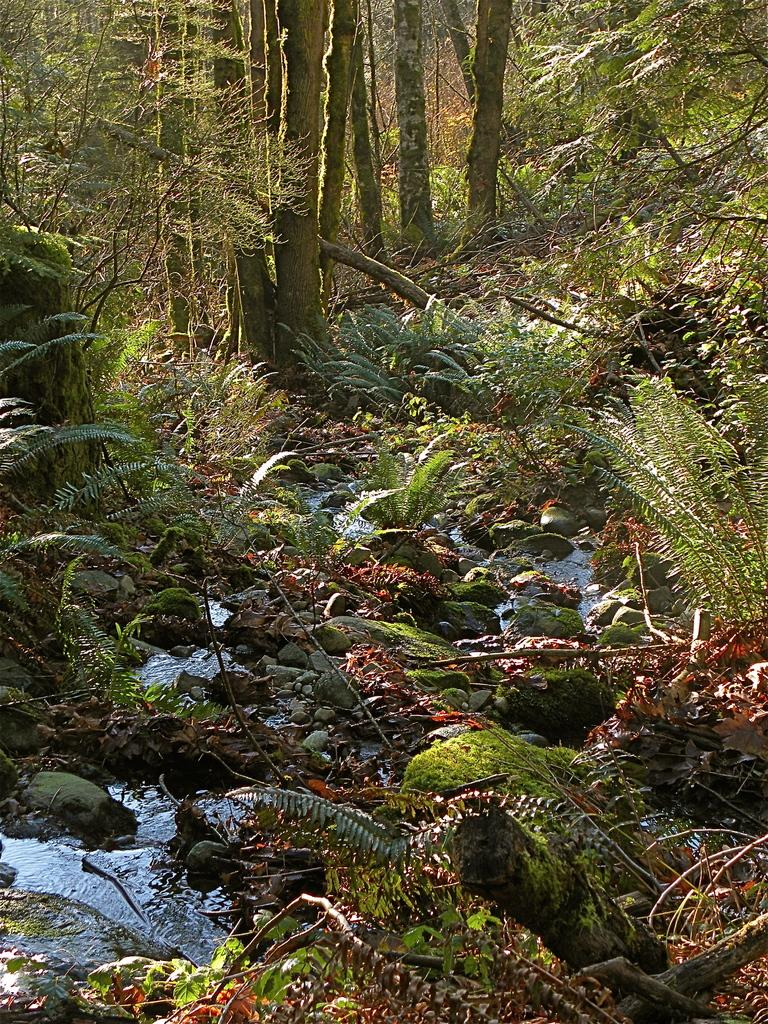What is the primary element visible in the image? There is water in the image. What other objects can be seen in the water? Stones are visible in the image. What celestial bodies are depicted on the left and right sides of the image? There are planets depicted on the left and right sides of the image. What type of natural environment is visible in the background of the image? Trees are present in the background of the image. What type of ear is visible on the planet depicted on the left side of the image? There is no ear present on the planet depicted on the left side of the image, as planets do not have ears. 